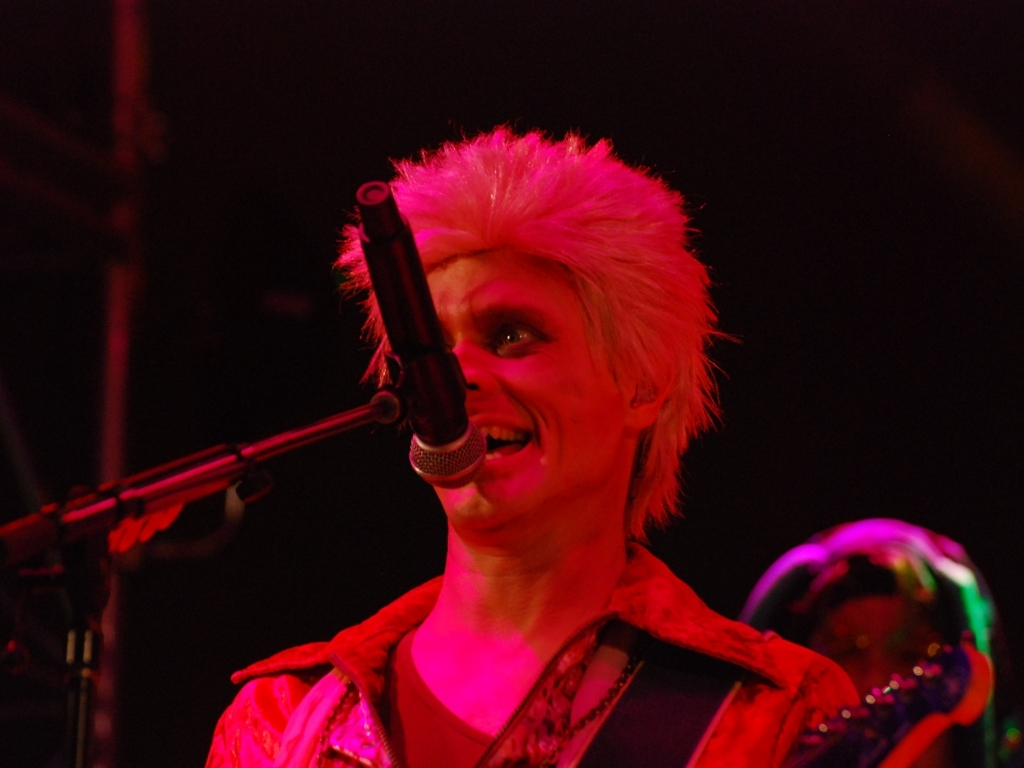What is the focus of the image?
A. singer and microphone
B. instruments
C. stage The focus of the image is clearly on the singer who is using the microphone. The individual is shown in performance mode, appearing engaged with their act of singing or speaking. The combination of vibrant hair color and expressive facial features creates a dynamic center of attention. 